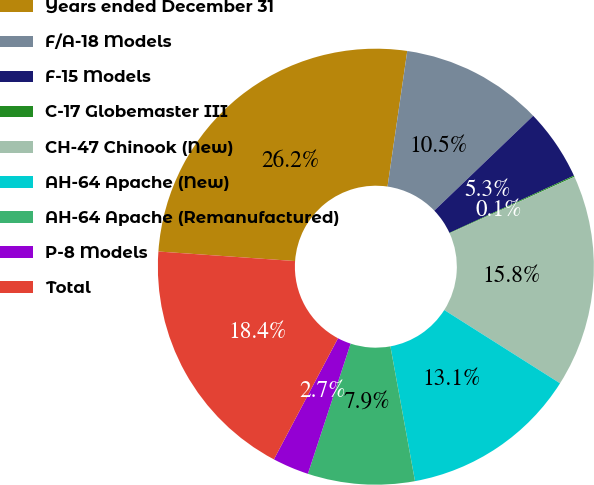Convert chart to OTSL. <chart><loc_0><loc_0><loc_500><loc_500><pie_chart><fcel>Years ended December 31<fcel>F/A-18 Models<fcel>F-15 Models<fcel>C-17 Globemaster III<fcel>CH-47 Chinook (New)<fcel>AH-64 Apache (New)<fcel>AH-64 Apache (Remanufactured)<fcel>P-8 Models<fcel>Total<nl><fcel>26.19%<fcel>10.53%<fcel>5.31%<fcel>0.09%<fcel>15.75%<fcel>13.14%<fcel>7.92%<fcel>2.7%<fcel>18.36%<nl></chart> 